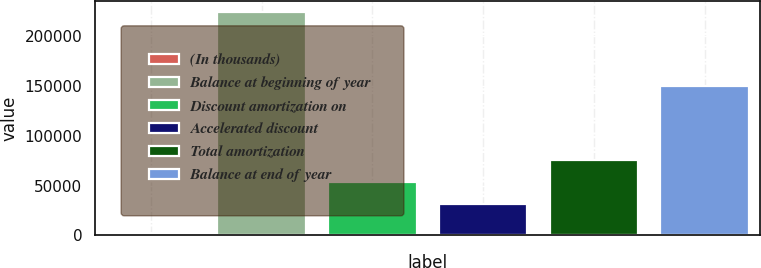<chart> <loc_0><loc_0><loc_500><loc_500><bar_chart><fcel>(In thousands)<fcel>Balance at beginning of year<fcel>Discount amortization on<fcel>Accelerated discount<fcel>Total amortization<fcel>Balance at end of year<nl><fcel>2012<fcel>224206<fcel>53751.4<fcel>31532<fcel>75970.8<fcel>149333<nl></chart> 